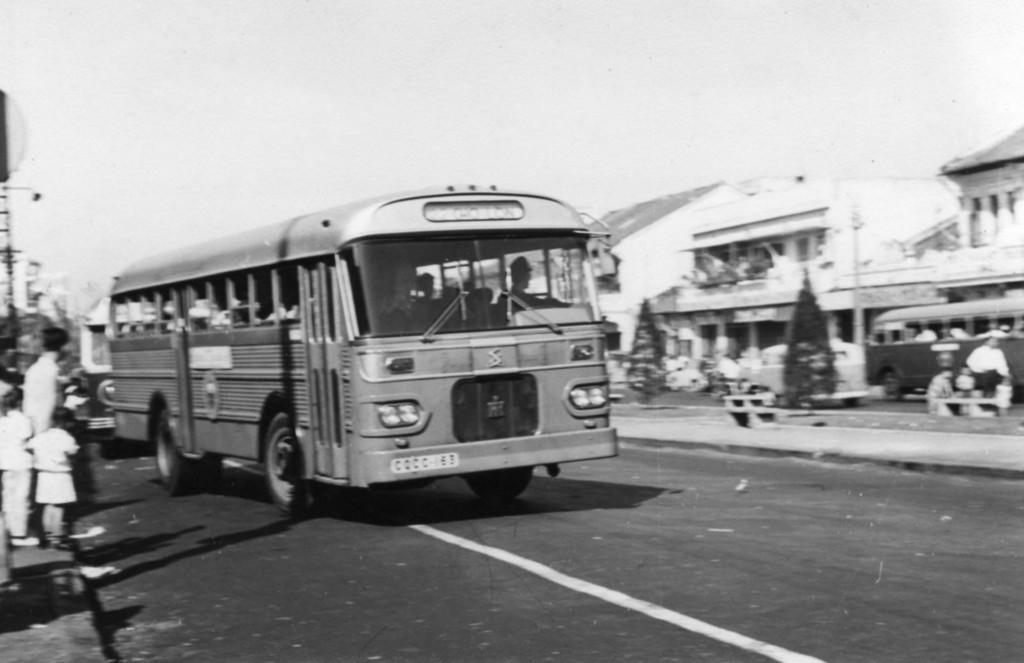Who or what is located on the left side of the image? There are people on the left side of the image. What can be seen in the foreground of the image? There are buses in the foreground of the image. What is present on the right side of the image? There are buses on the right side of the image. What is the surface that the buses are on? There is a road at the bottom of the image. What is visible at the top of the image? The sky is visible at the top of the image. What type of dress is the zinc wearing in the image? There is no zinc or dress present in the image. What language are the people speaking in the image? The provided facts do not mention the language spoken by the people in the image. 